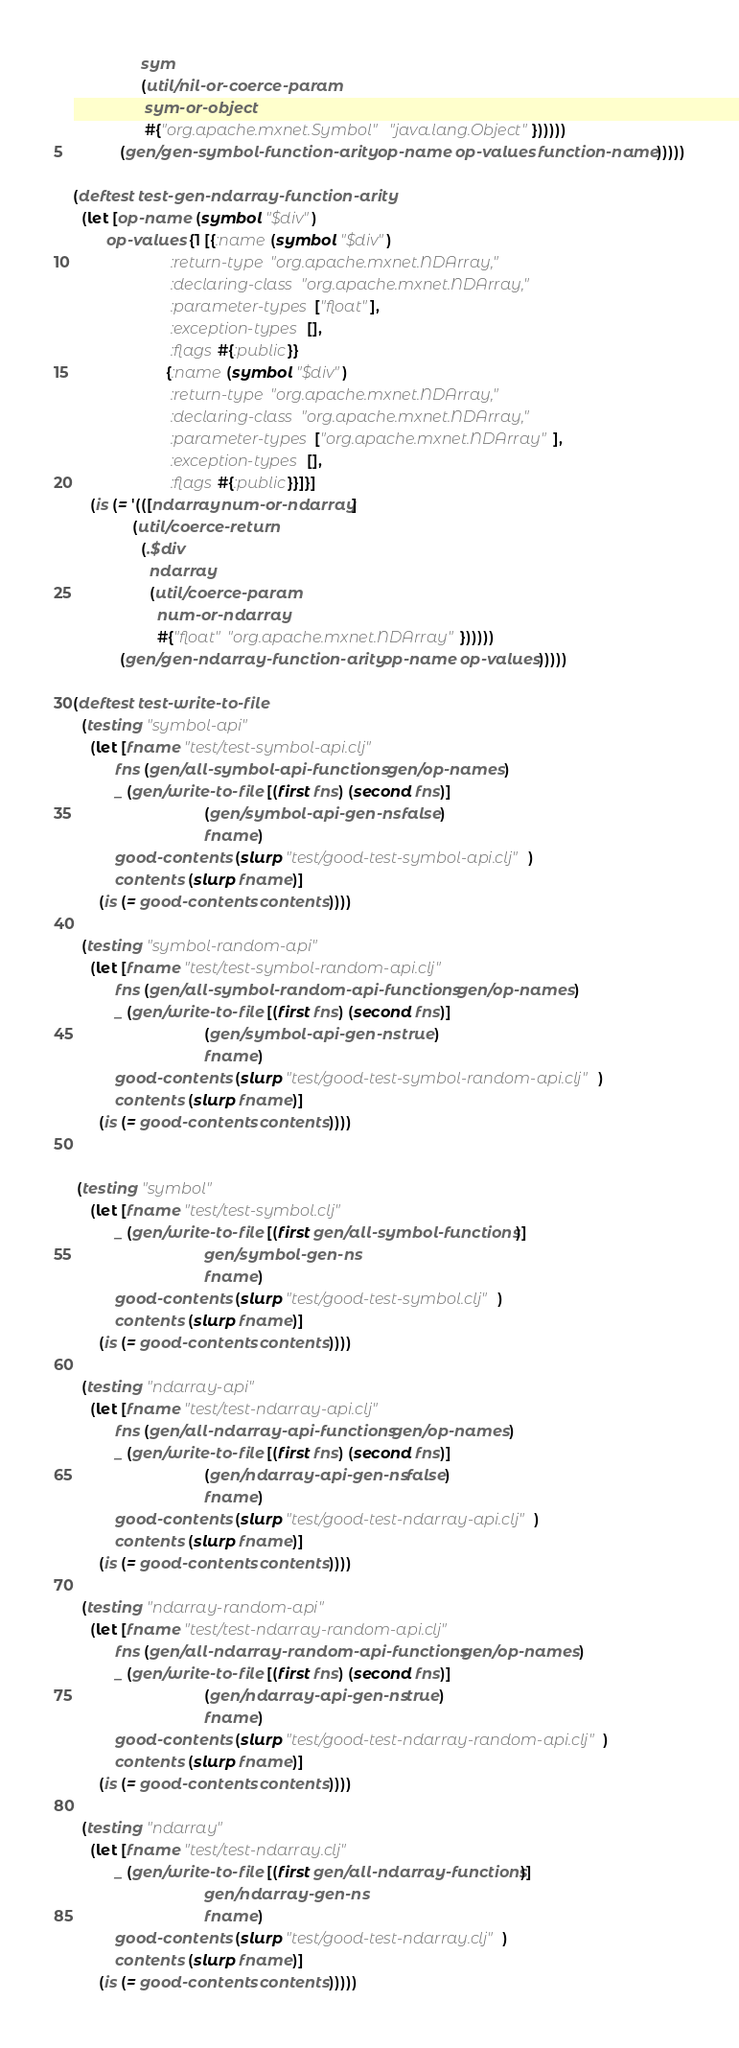<code> <loc_0><loc_0><loc_500><loc_500><_Clojure_>                sym
                (util/nil-or-coerce-param
                 sym-or-object
                 #{"org.apache.mxnet.Symbol" "java.lang.Object"})))))
           (gen/gen-symbol-function-arity op-name op-values function-name)))))

(deftest test-gen-ndarray-function-arity
  (let [op-name (symbol "$div")
        op-values {1 [{:name (symbol "$div")
                       :return-type "org.apache.mxnet.NDArray,"
                       :declaring-class "org.apache.mxnet.NDArray,"
                       :parameter-types ["float"],
                       :exception-types [],
                       :flags #{:public}}
                      {:name (symbol "$div")
                       :return-type "org.apache.mxnet.NDArray,"
                       :declaring-class "org.apache.mxnet.NDArray,"
                       :parameter-types ["org.apache.mxnet.NDArray"],
                       :exception-types [],
                       :flags #{:public}}]}]
    (is (= '(([ndarray num-or-ndarray]
              (util/coerce-return
                (.$div
                  ndarray
                  (util/coerce-param
                    num-or-ndarray
                    #{"float" "org.apache.mxnet.NDArray"})))))
           (gen/gen-ndarray-function-arity op-name op-values)))))

(deftest test-write-to-file
  (testing "symbol-api"
    (let [fname "test/test-symbol-api.clj"
          fns (gen/all-symbol-api-functions gen/op-names)
          _ (gen/write-to-file [(first fns) (second fns)]
                               (gen/symbol-api-gen-ns false)
                               fname)
          good-contents (slurp "test/good-test-symbol-api.clj")
          contents (slurp fname)]
      (is (= good-contents contents))))

  (testing "symbol-random-api"
    (let [fname "test/test-symbol-random-api.clj"
          fns (gen/all-symbol-random-api-functions gen/op-names)
          _ (gen/write-to-file [(first fns) (second fns)]
                               (gen/symbol-api-gen-ns true)
                               fname)
          good-contents (slurp "test/good-test-symbol-random-api.clj")
          contents (slurp fname)]
      (is (= good-contents contents))))


 (testing "symbol"
    (let [fname "test/test-symbol.clj"
          _ (gen/write-to-file [(first gen/all-symbol-functions)]
                               gen/symbol-gen-ns
                               fname)
          good-contents (slurp "test/good-test-symbol.clj")
          contents (slurp fname)]
      (is (= good-contents contents))))

  (testing "ndarray-api"
    (let [fname "test/test-ndarray-api.clj"
          fns (gen/all-ndarray-api-functions gen/op-names)
          _ (gen/write-to-file [(first fns) (second fns)]
                               (gen/ndarray-api-gen-ns false)
                               fname)
          good-contents (slurp "test/good-test-ndarray-api.clj")
          contents (slurp fname)]
      (is (= good-contents contents))))

  (testing "ndarray-random-api"
    (let [fname "test/test-ndarray-random-api.clj"
          fns (gen/all-ndarray-random-api-functions gen/op-names)
          _ (gen/write-to-file [(first fns) (second fns)]
                               (gen/ndarray-api-gen-ns true)
                               fname)
          good-contents (slurp "test/good-test-ndarray-random-api.clj")
          contents (slurp fname)]
      (is (= good-contents contents))))

  (testing "ndarray"
    (let [fname "test/test-ndarray.clj"
          _ (gen/write-to-file [(first gen/all-ndarray-functions)]
                               gen/ndarray-gen-ns
                               fname)
          good-contents (slurp "test/good-test-ndarray.clj")
          contents (slurp fname)]
      (is (= good-contents contents)))))
</code> 